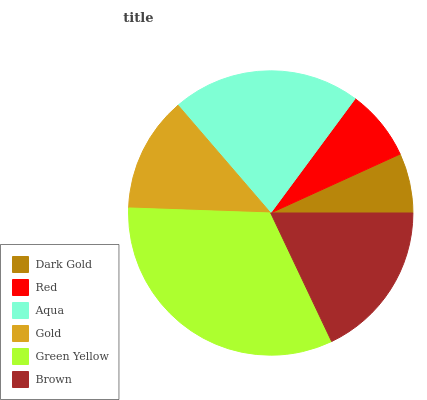Is Dark Gold the minimum?
Answer yes or no. Yes. Is Green Yellow the maximum?
Answer yes or no. Yes. Is Red the minimum?
Answer yes or no. No. Is Red the maximum?
Answer yes or no. No. Is Red greater than Dark Gold?
Answer yes or no. Yes. Is Dark Gold less than Red?
Answer yes or no. Yes. Is Dark Gold greater than Red?
Answer yes or no. No. Is Red less than Dark Gold?
Answer yes or no. No. Is Brown the high median?
Answer yes or no. Yes. Is Gold the low median?
Answer yes or no. Yes. Is Red the high median?
Answer yes or no. No. Is Dark Gold the low median?
Answer yes or no. No. 